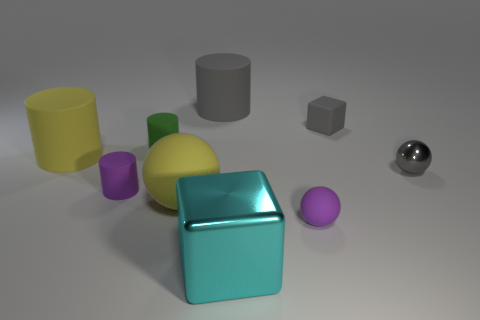Subtract all cubes. How many objects are left? 7 Add 7 tiny gray metallic objects. How many tiny gray metallic objects exist? 8 Subtract 0 red cylinders. How many objects are left? 9 Subtract all tiny gray matte blocks. Subtract all small gray rubber blocks. How many objects are left? 7 Add 8 purple cylinders. How many purple cylinders are left? 9 